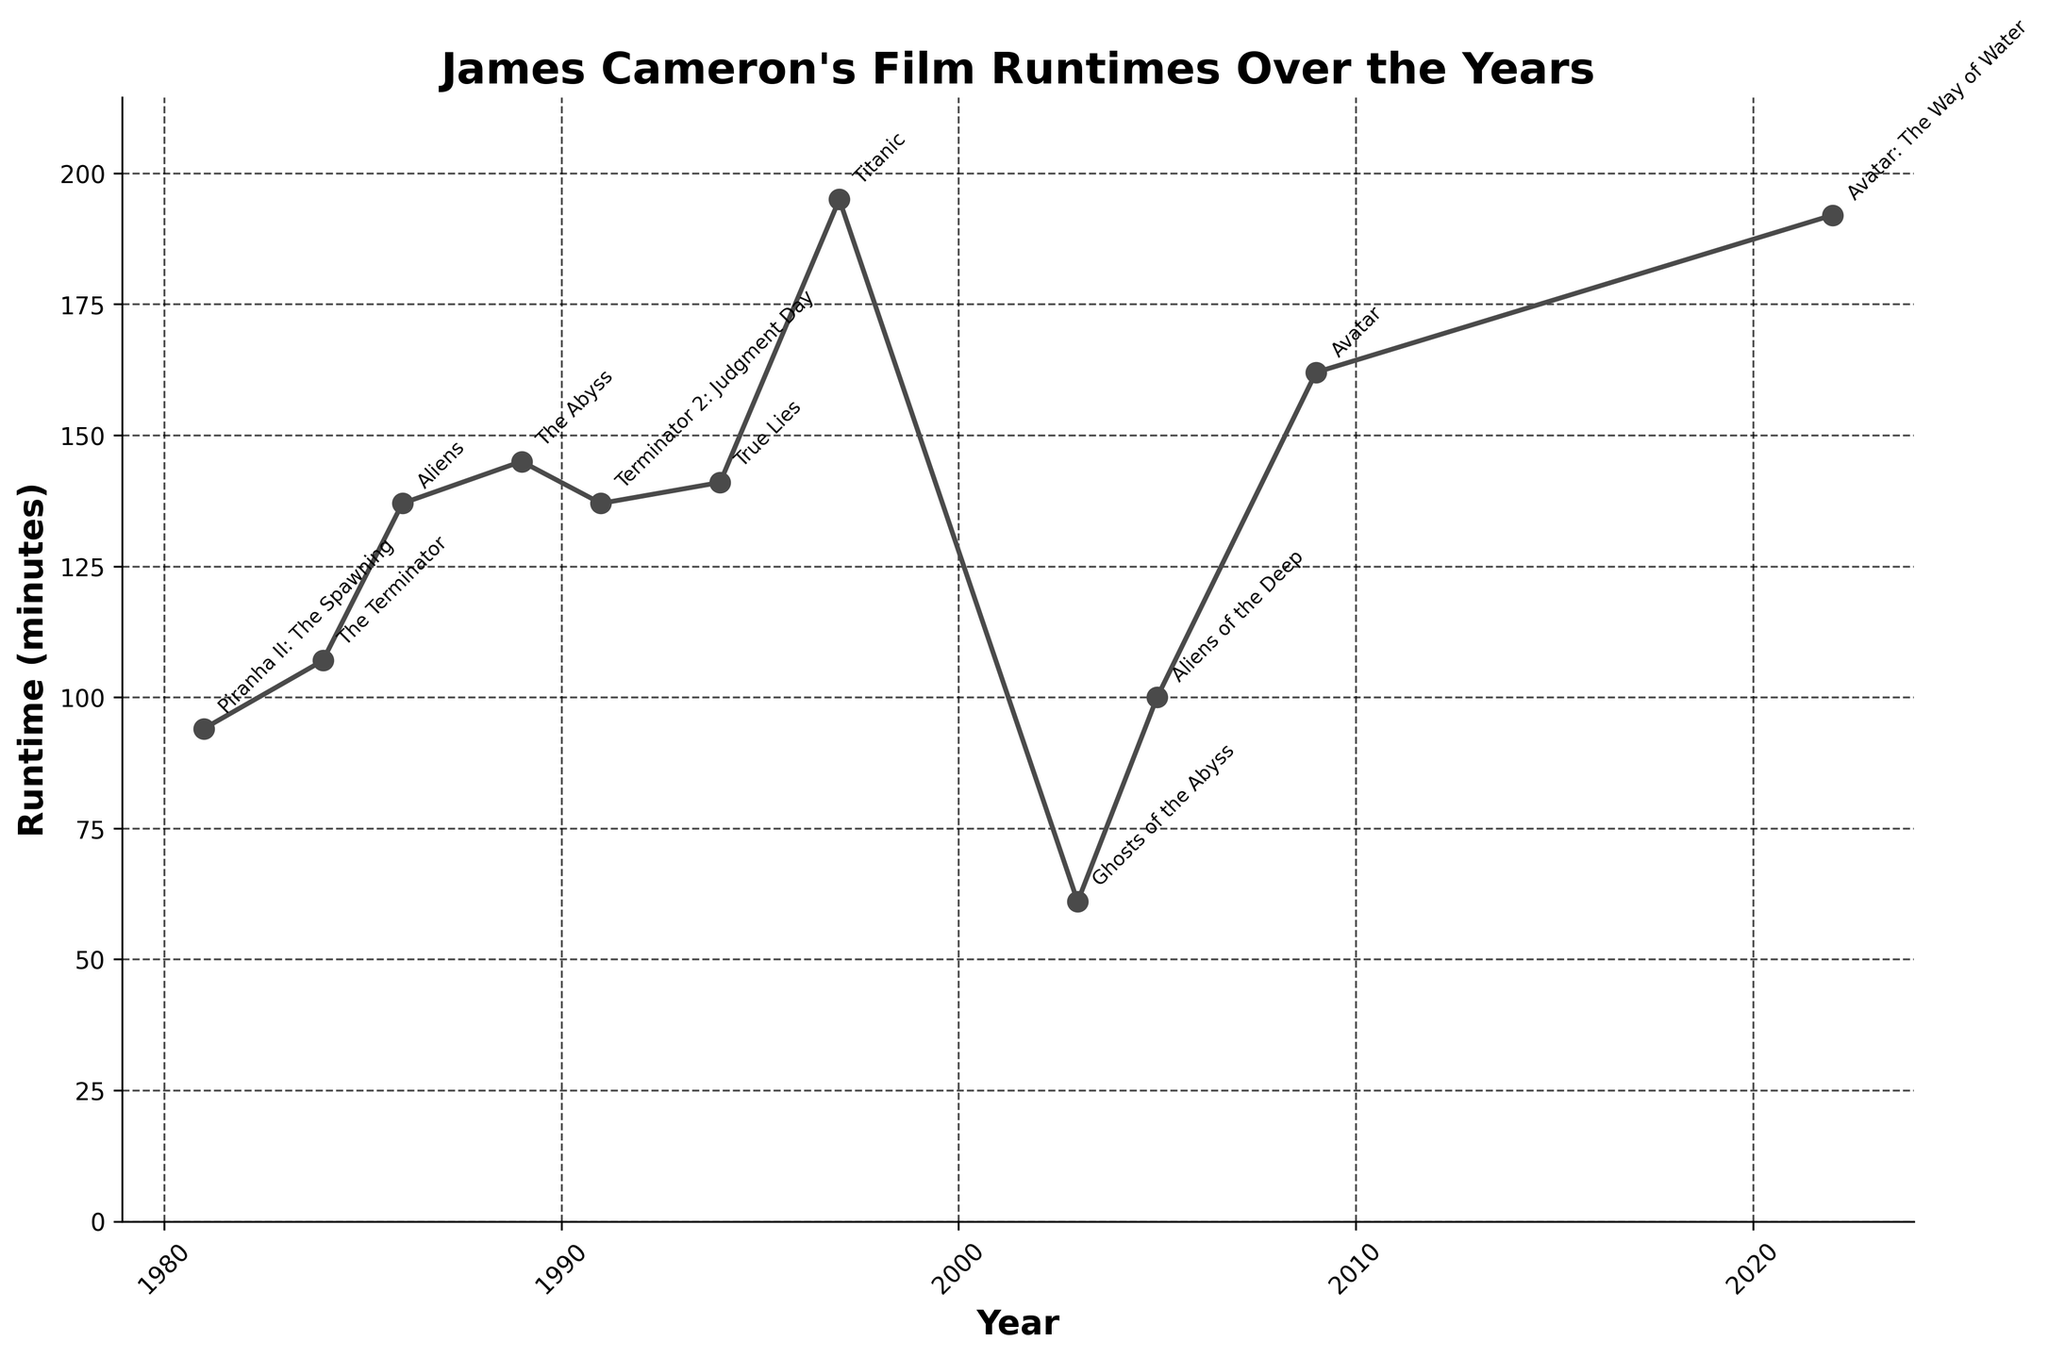What's the longest film directed by James Cameron according to the figure? First, locate the highest point on the line. Next, identify the film title associated with this point through its label.
Answer: "Titanic" with a runtime of 195 minutes What's the difference in runtime between the shortest and longest films by James Cameron? Identify the shortest film by finding the lowest point on the line, which is "Ghosts of the Abyss" at 61 minutes. Identify the longest film by finding the highest point on the line, which is "Titanic" at 195 minutes. Compute the difference: 195 - 61 = 134 minutes.
Answer: 134 minutes Which film shows a significant drop in runtime after the lengthy "Titanic"? Identify "Titanic" at 195 minutes in 1997. See that the next film after "Titanic" is "Ghosts of the Abyss" in 2003 with a runtime of 61 minutes.
Answer: "Ghosts of the Abyss" What is the average runtime of James Cameron's films released in the 1990s? Identify the films released in the 1990s: "The Abyss" (145 minutes, 1989), "Terminator 2: Judgment Day" (137 minutes, 1991), "True Lies" (141 minutes, 1994), and "Titanic" (195 minutes, 1997). For simplicity, just use the three films from the 1990s: (137 + 141 + 195)/3 = 473/3 ≈ 157.67 minutes.
Answer: Approximately 157.67 minutes Which decade experienced the highest average runtime of James Cameron's films? Calculate the average runtime for each decade:
1980s: (94 + 107 + 137 + 145)/4 = 483/4 = 120.75 minutes
1990s: (137 + 141 + 195)/3 ≈ 157.67 minutes
2000s: (61 + 100 + 162)/3 = 323/3 ≈ 107.67 minutes
2020s: (192)
Comparing the averages, the 1990s have the highest average runtime.
Answer: 1990s Which films show no change in runtime compared to their immediate predecessors? Detect any flat segments in the line plot. The line is only horizontal between "Aliens" (1986) and "Terminator 2: Judgment Day" (1991), both with a runtime of 137 minutes.
Answer: "Aliens" and "Terminator 2: Judgment Day" How has the runtime of James Cameron's films evolved from his first to his latest film? Follow the trajectory of the line from the earliest to the latest year. The runtime starts at 94 minutes in 1981 ("Piranha II") and ends at 192 minutes in 2022 ("Avatar: The Way of Water"). Overall, there is an increasing trend over the years.
Answer: Increasing trend In which period did James Cameron release films with significantly shorter runtimes than in other periods? Identify the general timeframes and compare the runtimes. Notably, around 2003 ("Ghosts of the Abyss" at 61 minutes) and 2005 ("Aliens of the Deep" at 100 minutes), the runtimes are shorter compared to other periods.
Answer: Early 2000s What is the frequency of films with runtimes greater than 150 minutes? Identify films with runtimes above 150 minutes: "Titanic" (195 minutes), "Avatar" (162 minutes), "Avatar: The Way of Water" (192 minutes). Count these occurrences.
Answer: 3 films 